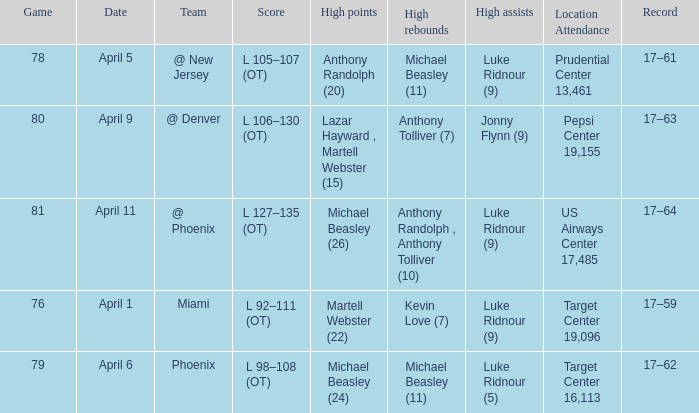In how many different games did Luke Ridnour (5) did the most high assists? 1.0. 